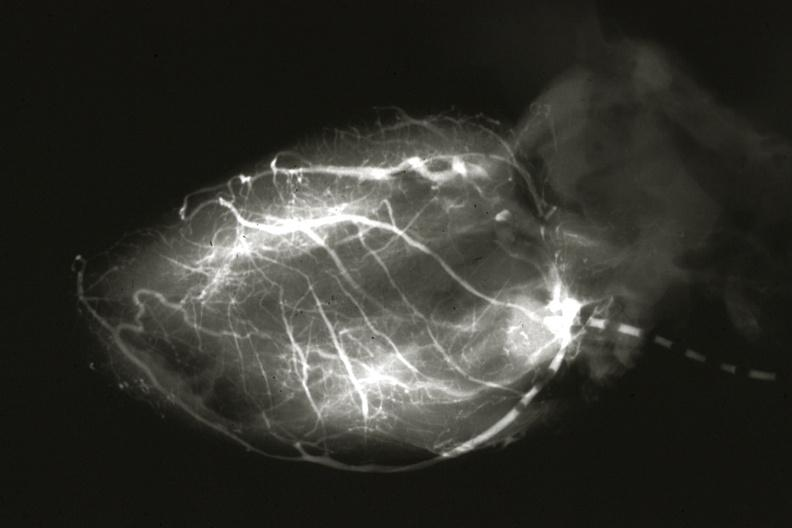what does this image show?
Answer the question using a single word or phrase. Angiogram postmortafter switch of left coronary to aorta 